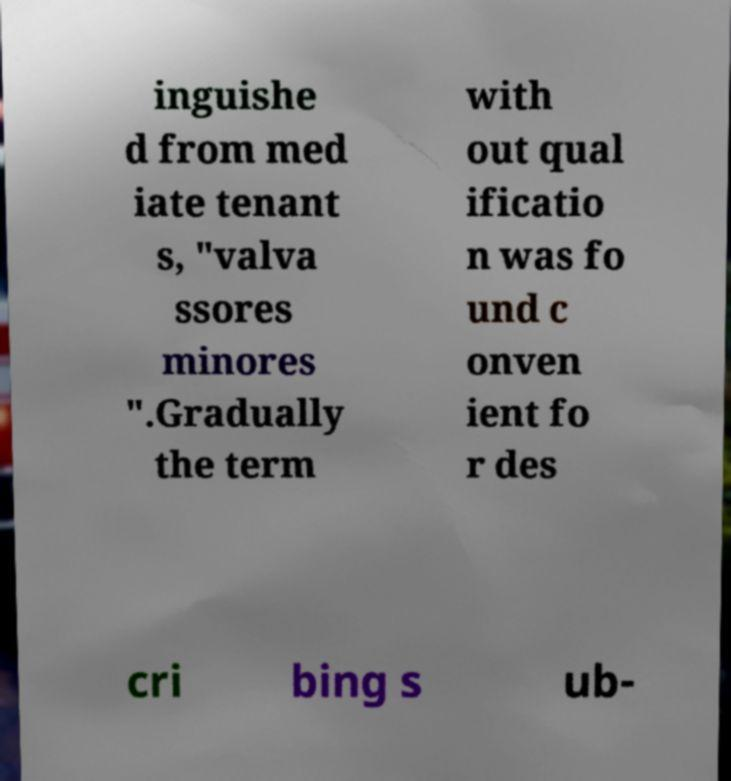Can you read and provide the text displayed in the image?This photo seems to have some interesting text. Can you extract and type it out for me? inguishe d from med iate tenant s, "valva ssores minores ".Gradually the term with out qual ificatio n was fo und c onven ient fo r des cri bing s ub- 